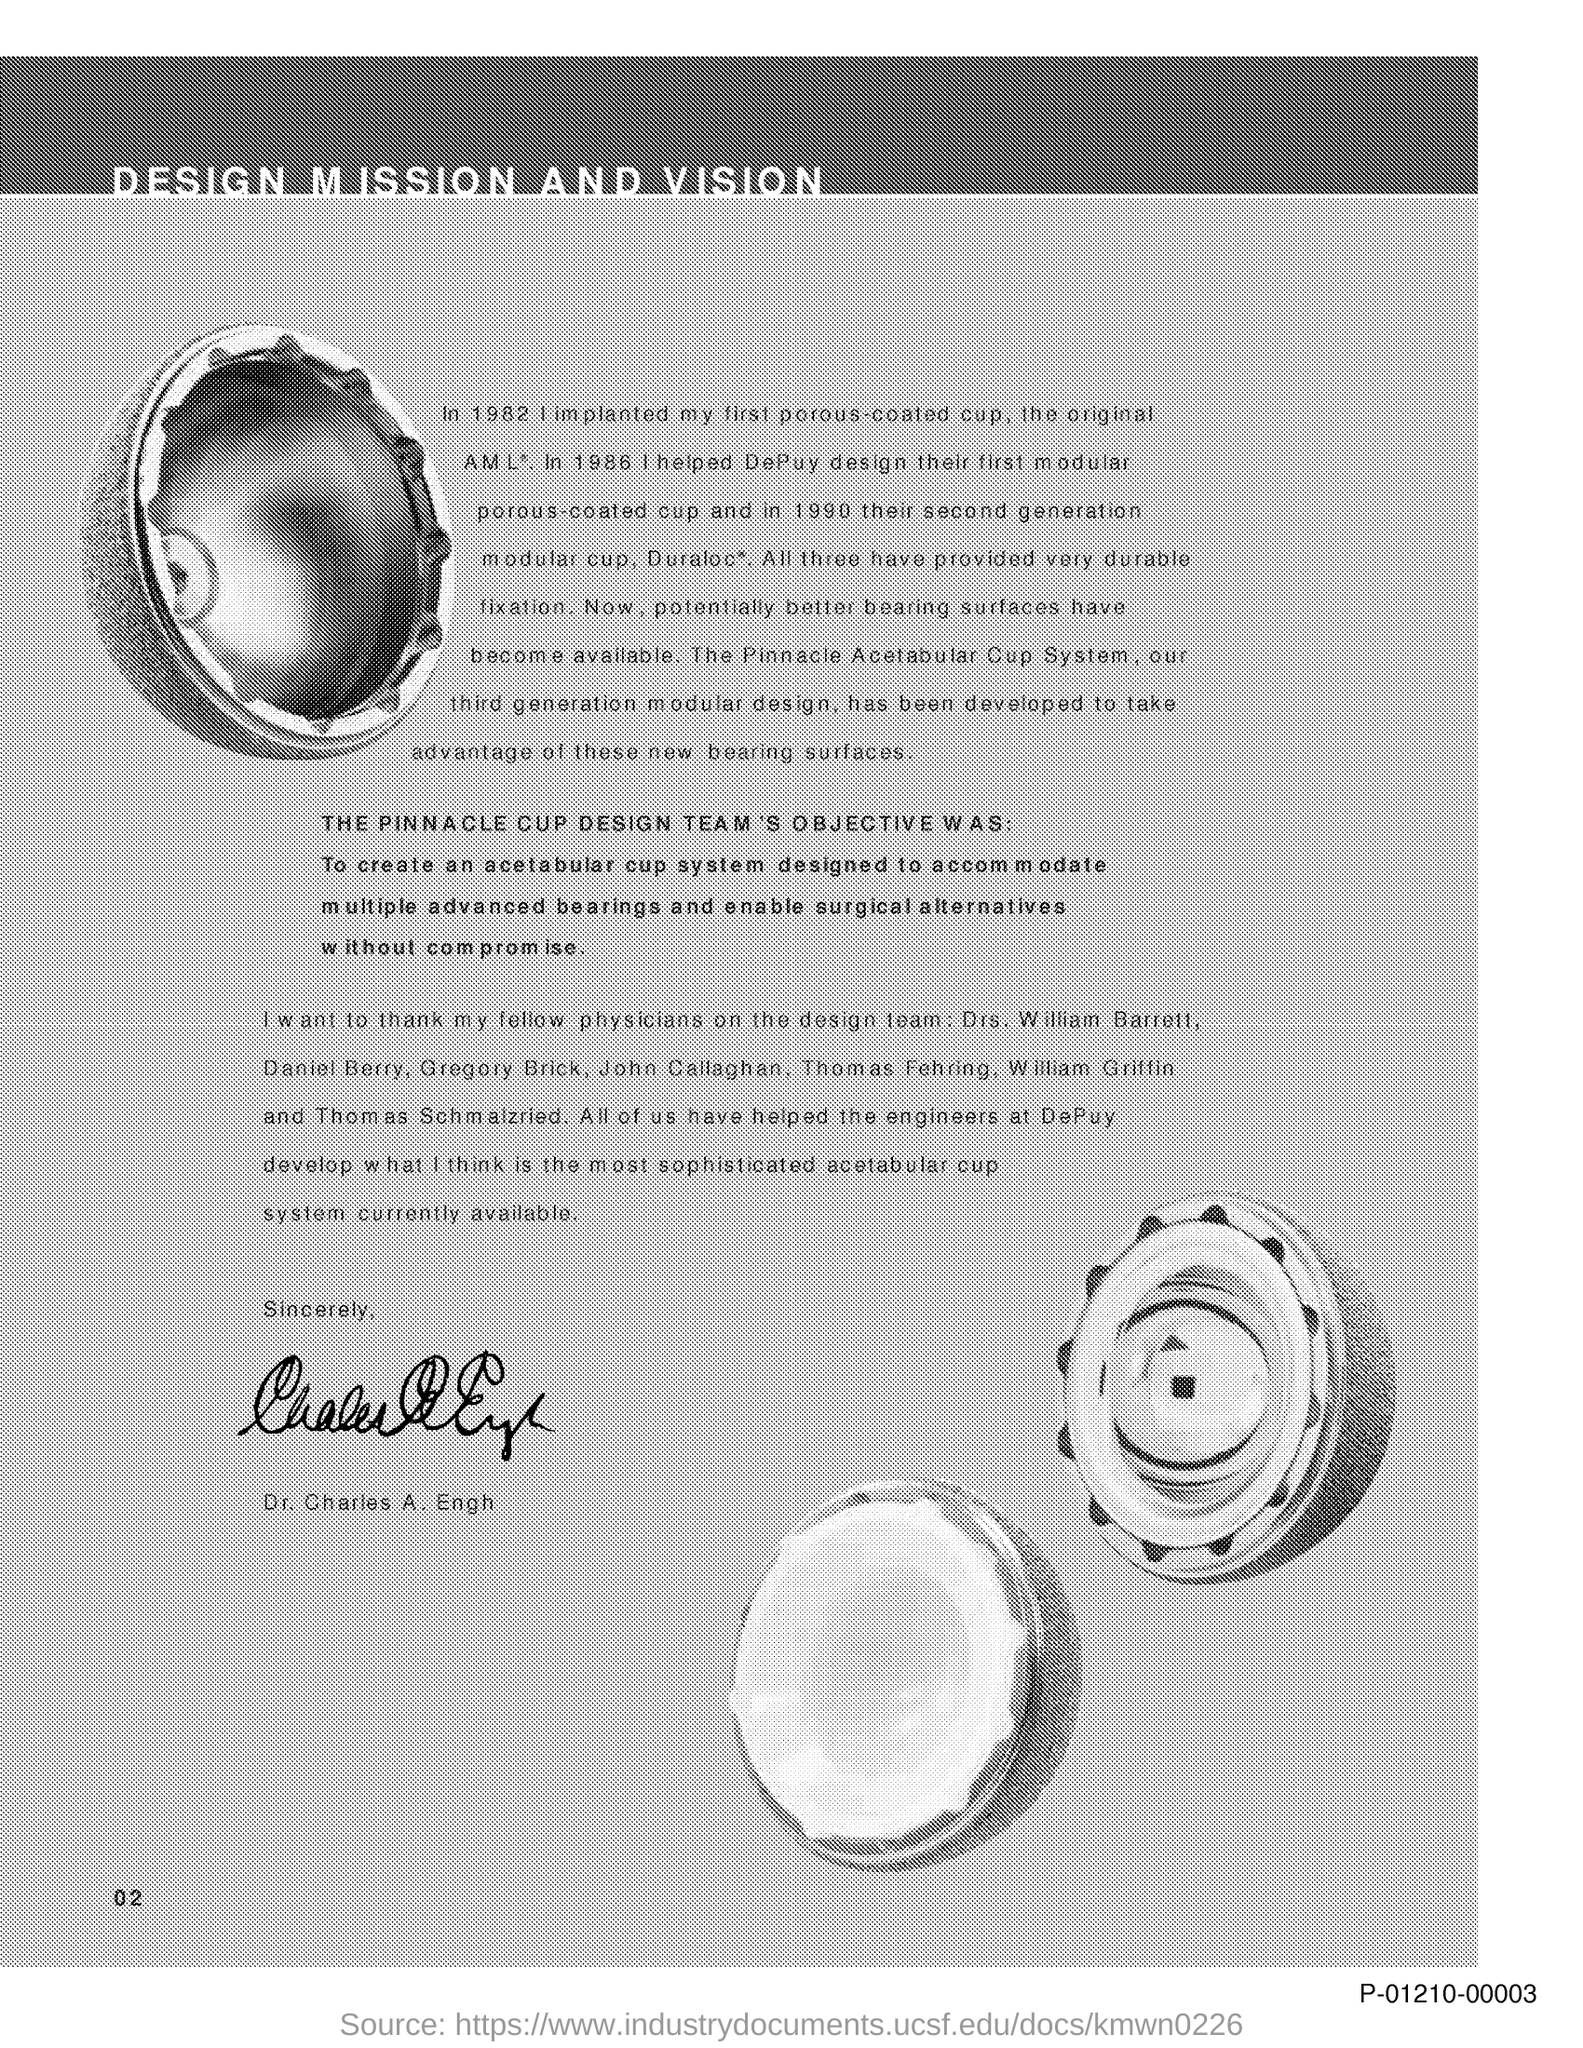Indicate a few pertinent items in this graphic. The title of the document is 'Design Mission and Vision'. 